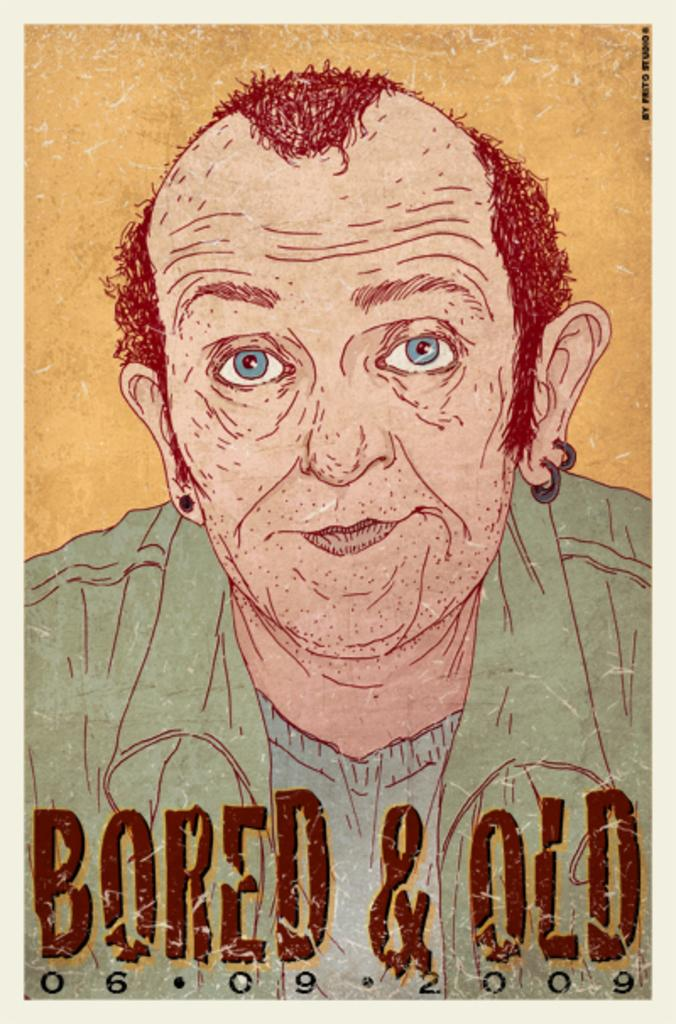<image>
Summarize the visual content of the image. A painting of an old man with the caption Bored & Old. 